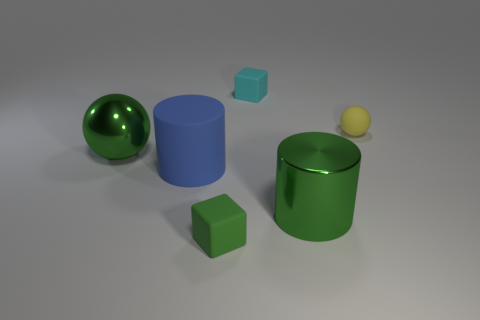What is the object that is in front of the big matte cylinder and on the right side of the green rubber block made of?
Your response must be concise. Metal. How many objects are either big green objects or small rubber spheres?
Offer a very short reply. 3. Are there more big metal balls than rubber objects?
Provide a short and direct response. No. How big is the metal thing that is on the left side of the small cube behind the green matte block?
Provide a short and direct response. Large. There is another object that is the same shape as the tiny cyan matte thing; what color is it?
Keep it short and to the point. Green. The blue thing is what size?
Make the answer very short. Large. What number of balls are either green matte objects or big things?
Offer a very short reply. 1. There is another thing that is the same shape as the blue matte thing; what is its size?
Give a very brief answer. Large. What number of tiny cyan matte objects are there?
Your answer should be very brief. 1. Is the shape of the cyan object the same as the green object behind the green cylinder?
Give a very brief answer. No. 